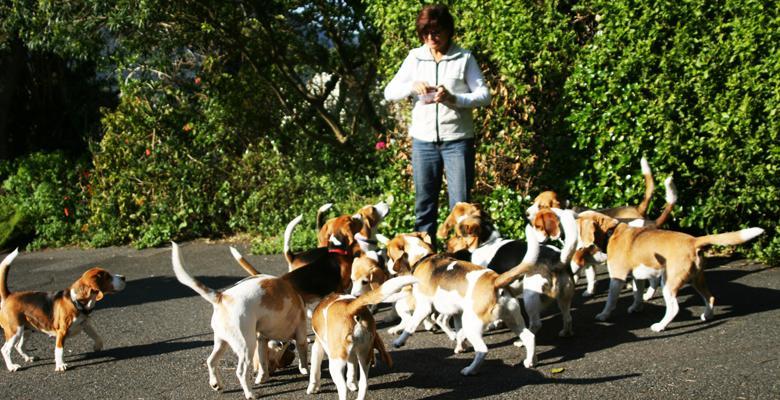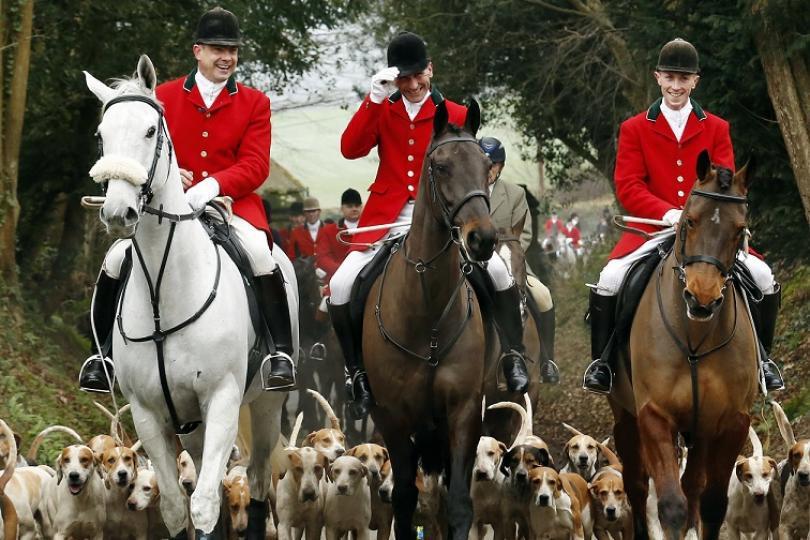The first image is the image on the left, the second image is the image on the right. For the images shown, is this caption "There is at least one person in a red jacket riding a horse in one of the images." true? Answer yes or no. Yes. The first image is the image on the left, the second image is the image on the right. Analyze the images presented: Is the assertion "An image shows a man in white pants astride a horse in the foreground, and includes someone in a red jacket somewhere in the scene." valid? Answer yes or no. Yes. 